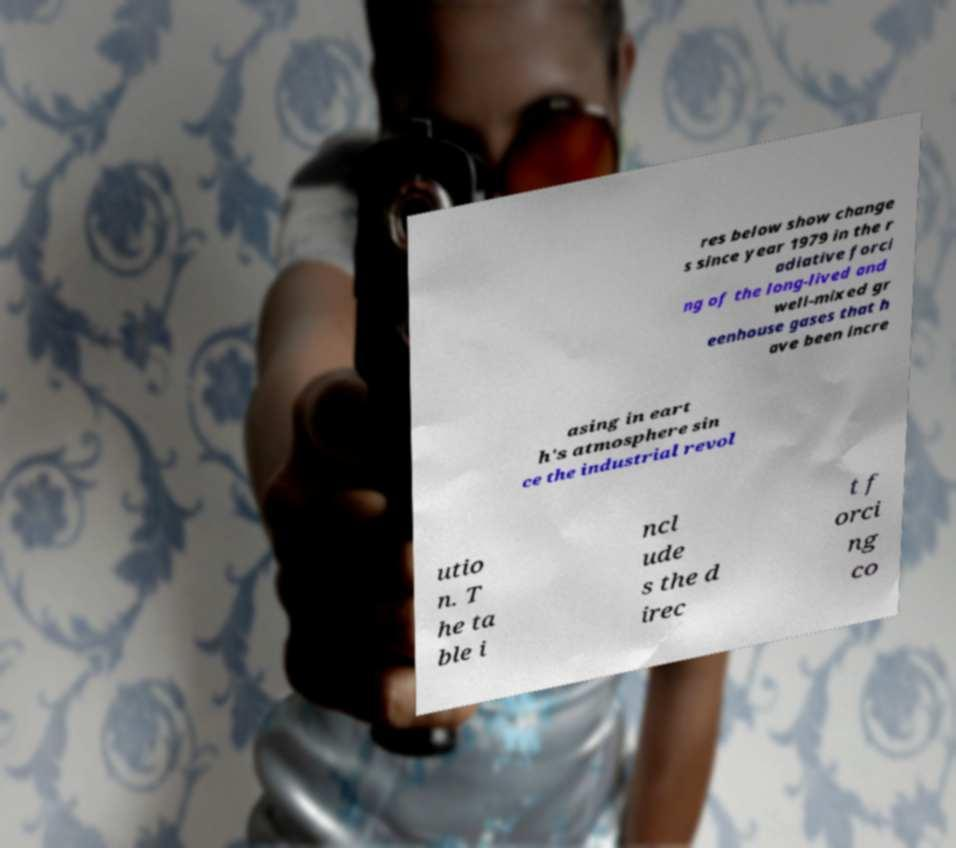Could you extract and type out the text from this image? res below show change s since year 1979 in the r adiative forci ng of the long-lived and well-mixed gr eenhouse gases that h ave been incre asing in eart h's atmosphere sin ce the industrial revol utio n. T he ta ble i ncl ude s the d irec t f orci ng co 